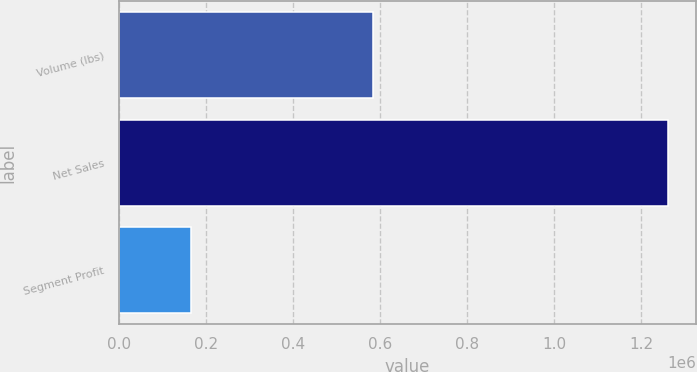Convert chart to OTSL. <chart><loc_0><loc_0><loc_500><loc_500><bar_chart><fcel>Volume (lbs)<fcel>Net Sales<fcel>Segment Profit<nl><fcel>583526<fcel>1.26205e+06<fcel>166253<nl></chart> 